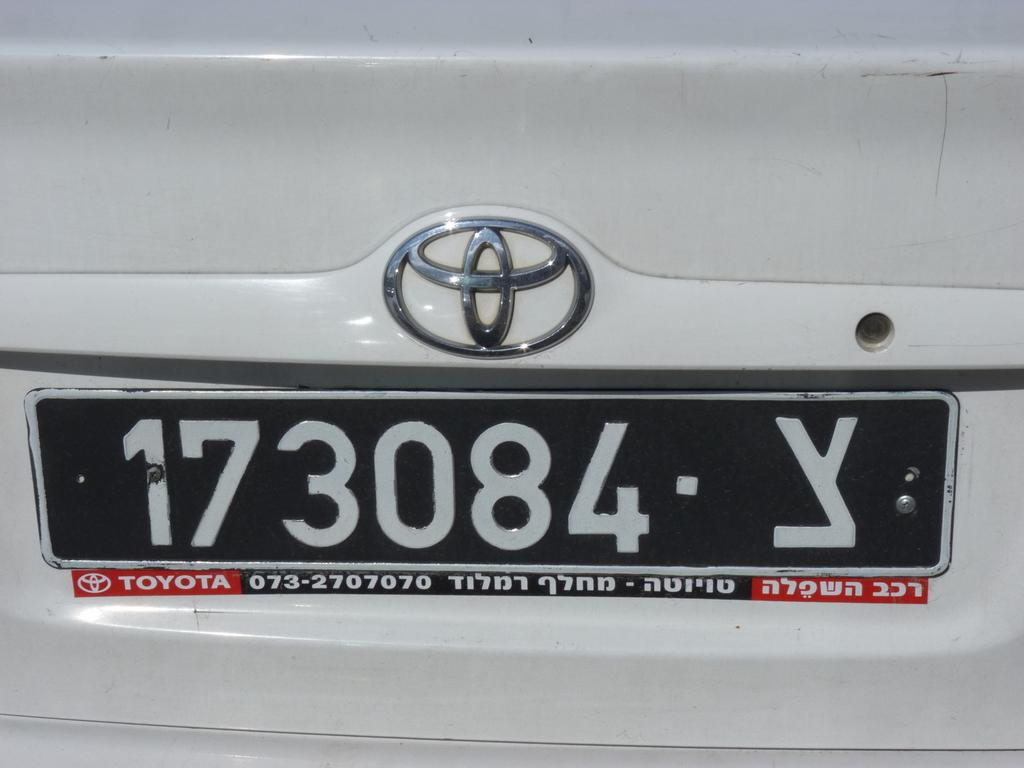Provide a one-sentence caption for the provided image. The boot of a white Toyota car, the number plate reads 1730084 Y. 